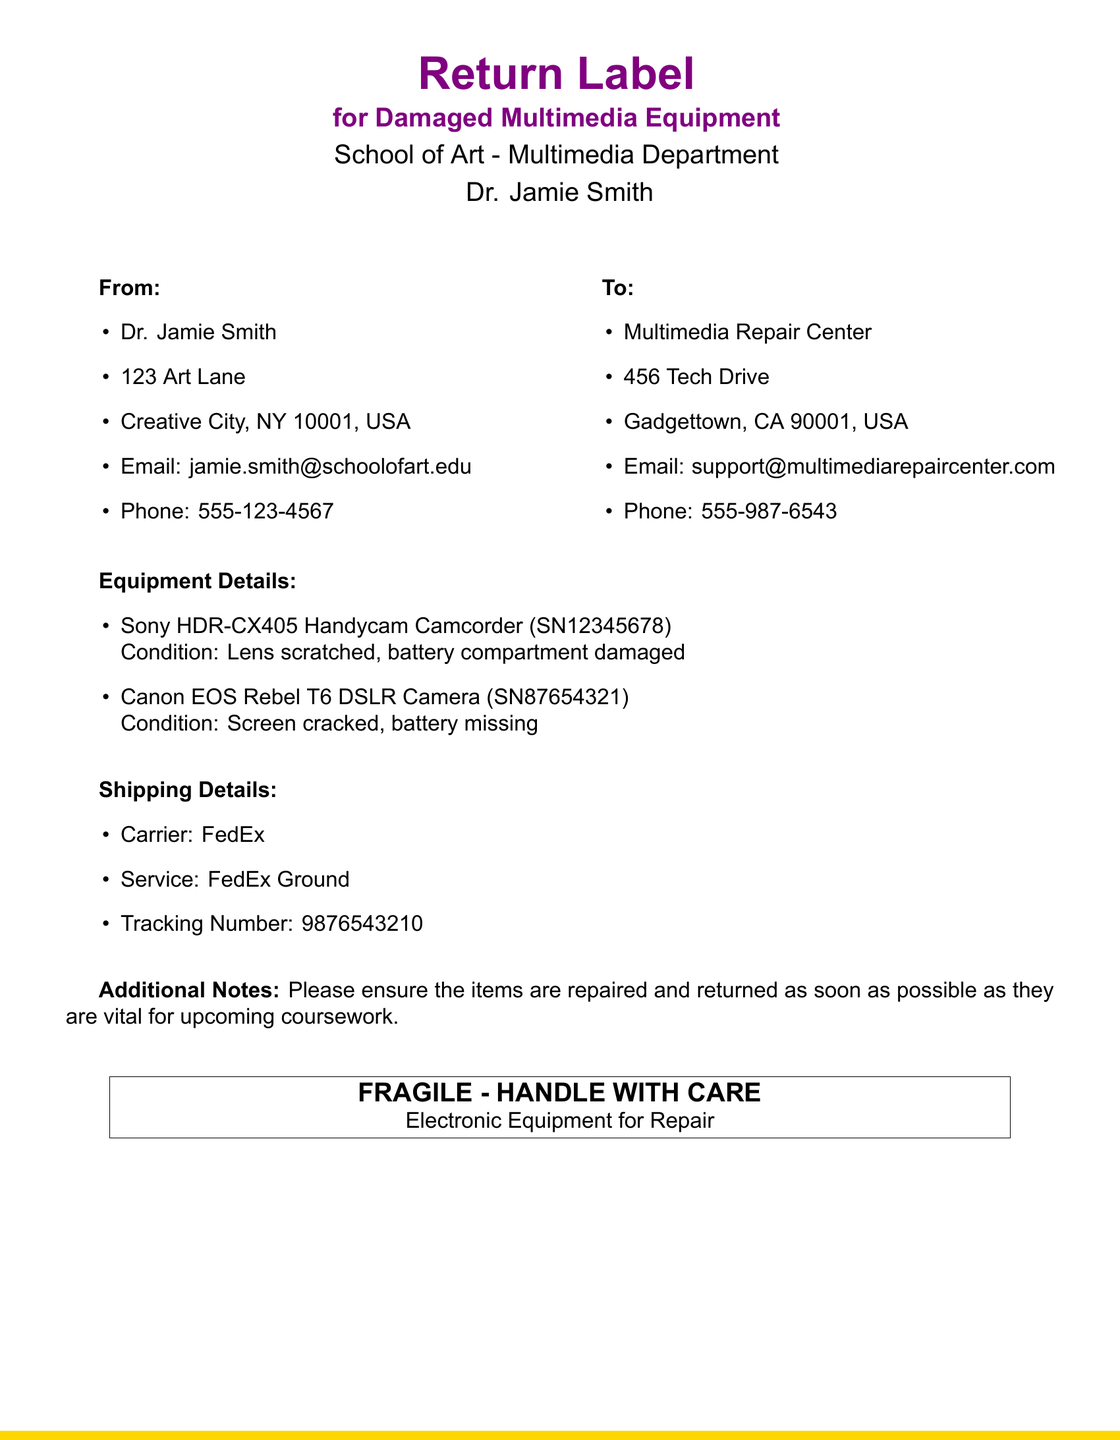What is the name of the sender? The sender's name is mentioned at the top of the document, which is Dr. Jamie Smith.
Answer: Dr. Jamie Smith What is the phone number of the sender? The phone number is listed under the sender's contact information, which is 555-123-4567.
Answer: 555-123-4567 What is the condition of the Sony camera? The condition is specified in the equipment details section, stating that the lens is scratched and the battery compartment is damaged.
Answer: Lens scratched, battery compartment damaged What carrier is used for shipping? The shipping details section specifies that the carrier used is FedEx.
Answer: FedEx What is the tracking number for the shipment? The tracking number is found in the shipping details section, which is stated as 9876543210.
Answer: 9876543210 What is the address of the Multimedia Repair Center? The address is listed under the recipient's information, provided as 456 Tech Drive, Gadgettown, CA 90001, USA.
Answer: 456 Tech Drive, Gadgettown, CA 90001, USA What type of service is used for shipping? The document specifies that the service used is FedEx Ground.
Answer: FedEx Ground Why is it important to repair and return the items quickly? The additional notes indicate that the items are vital for upcoming coursework, which emphasizes urgency.
Answer: Vital for upcoming coursework What message is enclosed within the box on the document? The enclosed message emphasizes handling instructions for the equipment, stating it is fragile and should be handled with care.
Answer: FRAGILE - HANDLE WITH CARE 